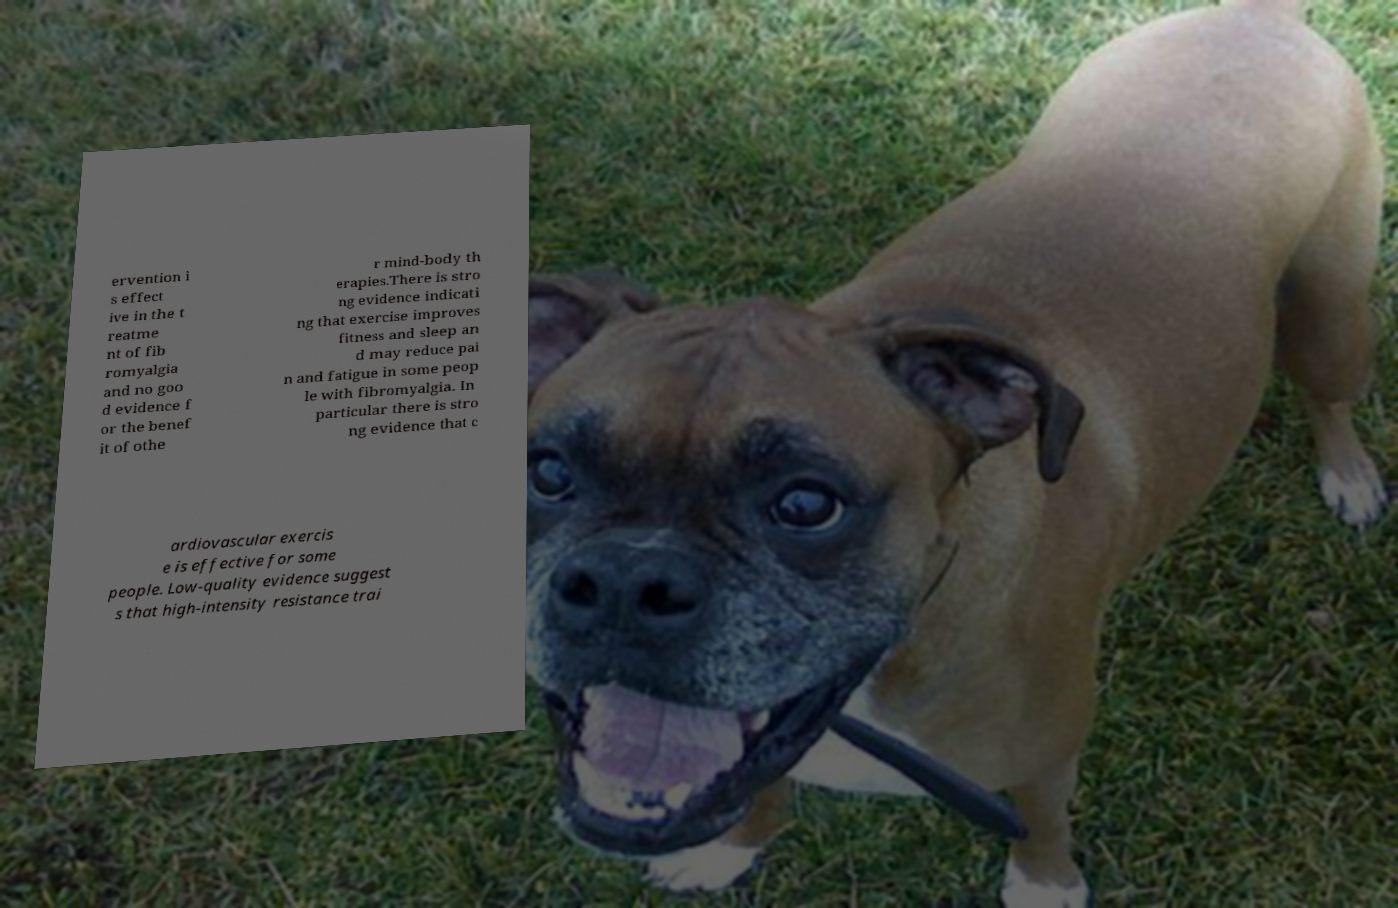Please read and relay the text visible in this image. What does it say? ervention i s effect ive in the t reatme nt of fib romyalgia and no goo d evidence f or the benef it of othe r mind-body th erapies.There is stro ng evidence indicati ng that exercise improves fitness and sleep an d may reduce pai n and fatigue in some peop le with fibromyalgia. In particular there is stro ng evidence that c ardiovascular exercis e is effective for some people. Low-quality evidence suggest s that high-intensity resistance trai 